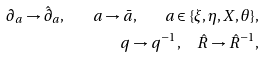Convert formula to latex. <formula><loc_0><loc_0><loc_500><loc_500>\partial _ { a } \rightarrow \hat { \partial } _ { a } , \quad a \rightarrow \bar { a } , \quad a \in \{ \xi , \eta , X , \theta \} , \\ q \rightarrow q ^ { - 1 } , \quad \hat { R } \rightarrow \hat { R } ^ { - 1 } ,</formula> 